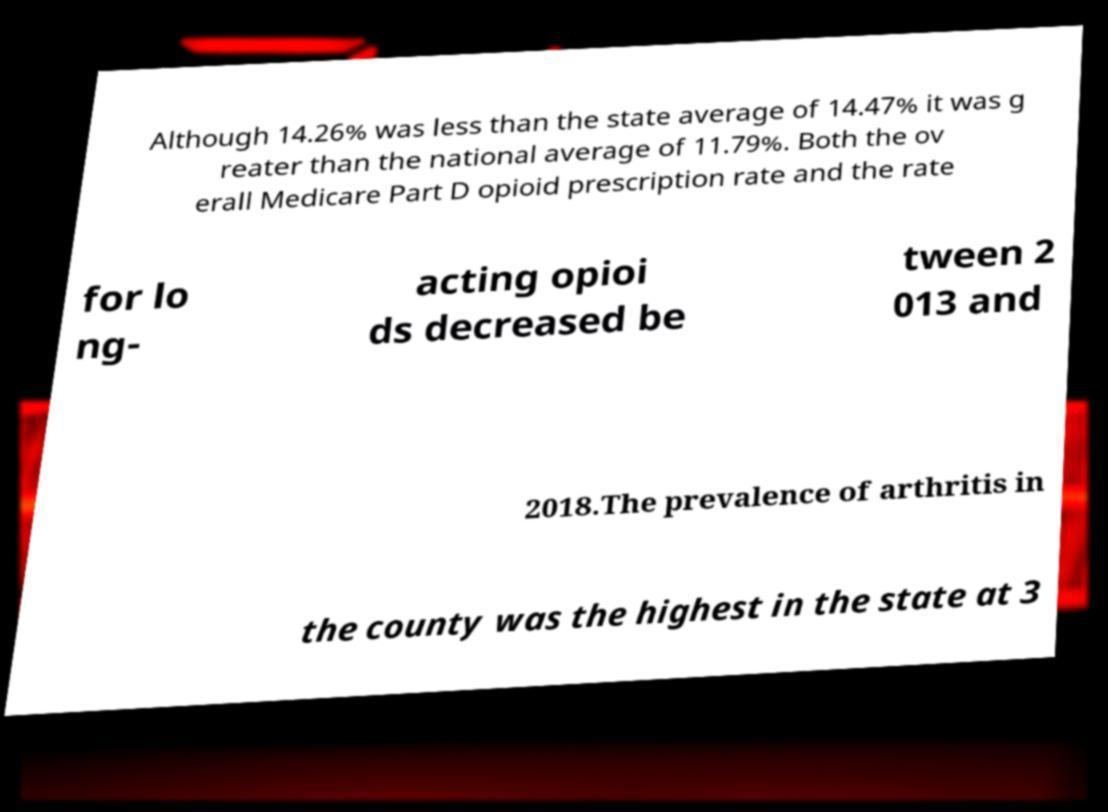Please identify and transcribe the text found in this image. Although 14.26% was less than the state average of 14.47% it was g reater than the national average of 11.79%. Both the ov erall Medicare Part D opioid prescription rate and the rate for lo ng- acting opioi ds decreased be tween 2 013 and 2018.The prevalence of arthritis in the county was the highest in the state at 3 